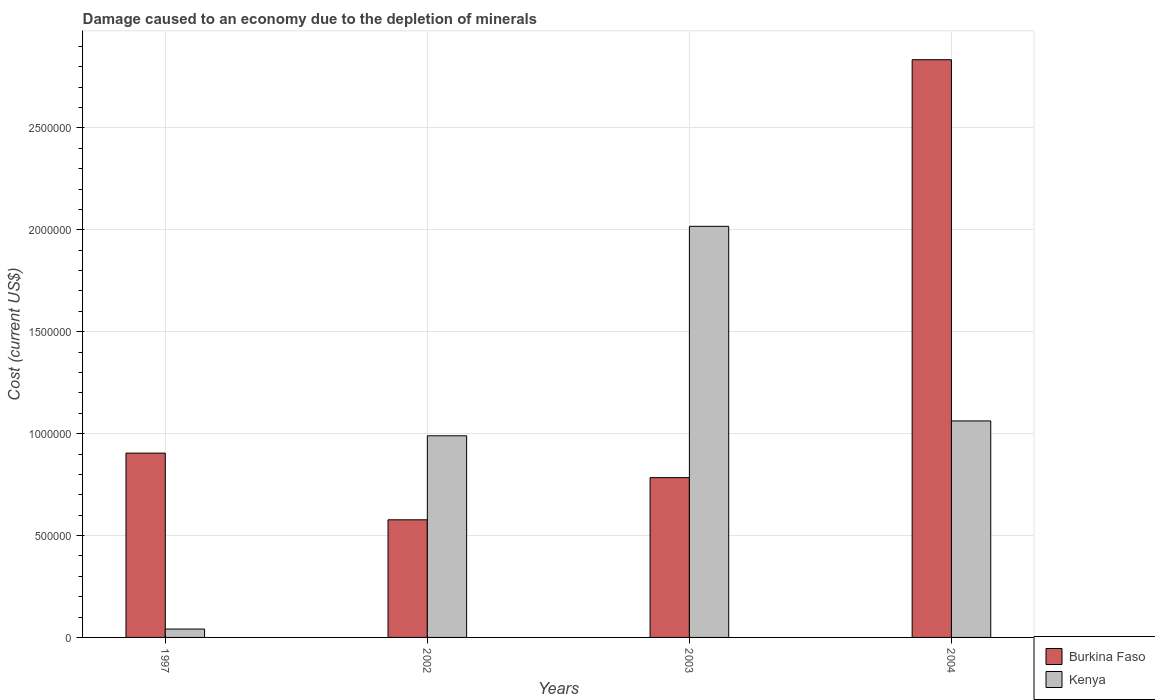How many different coloured bars are there?
Your answer should be very brief. 2. How many groups of bars are there?
Provide a short and direct response. 4. Are the number of bars per tick equal to the number of legend labels?
Keep it short and to the point. Yes. How many bars are there on the 2nd tick from the left?
Your answer should be very brief. 2. What is the label of the 2nd group of bars from the left?
Your answer should be very brief. 2002. In how many cases, is the number of bars for a given year not equal to the number of legend labels?
Your answer should be compact. 0. What is the cost of damage caused due to the depletion of minerals in Kenya in 2002?
Your response must be concise. 9.89e+05. Across all years, what is the maximum cost of damage caused due to the depletion of minerals in Kenya?
Ensure brevity in your answer.  2.02e+06. Across all years, what is the minimum cost of damage caused due to the depletion of minerals in Kenya?
Make the answer very short. 4.12e+04. In which year was the cost of damage caused due to the depletion of minerals in Burkina Faso maximum?
Your answer should be compact. 2004. What is the total cost of damage caused due to the depletion of minerals in Kenya in the graph?
Your answer should be very brief. 4.11e+06. What is the difference between the cost of damage caused due to the depletion of minerals in Burkina Faso in 1997 and that in 2002?
Keep it short and to the point. 3.27e+05. What is the difference between the cost of damage caused due to the depletion of minerals in Kenya in 2003 and the cost of damage caused due to the depletion of minerals in Burkina Faso in 2002?
Your response must be concise. 1.44e+06. What is the average cost of damage caused due to the depletion of minerals in Kenya per year?
Offer a very short reply. 1.03e+06. In the year 2004, what is the difference between the cost of damage caused due to the depletion of minerals in Kenya and cost of damage caused due to the depletion of minerals in Burkina Faso?
Your response must be concise. -1.77e+06. What is the ratio of the cost of damage caused due to the depletion of minerals in Kenya in 2003 to that in 2004?
Provide a succinct answer. 1.9. Is the difference between the cost of damage caused due to the depletion of minerals in Kenya in 2002 and 2003 greater than the difference between the cost of damage caused due to the depletion of minerals in Burkina Faso in 2002 and 2003?
Provide a short and direct response. No. What is the difference between the highest and the second highest cost of damage caused due to the depletion of minerals in Kenya?
Offer a terse response. 9.55e+05. What is the difference between the highest and the lowest cost of damage caused due to the depletion of minerals in Kenya?
Offer a very short reply. 1.98e+06. Is the sum of the cost of damage caused due to the depletion of minerals in Burkina Faso in 1997 and 2003 greater than the maximum cost of damage caused due to the depletion of minerals in Kenya across all years?
Your response must be concise. No. What does the 2nd bar from the left in 2003 represents?
Your answer should be compact. Kenya. What does the 1st bar from the right in 2003 represents?
Give a very brief answer. Kenya. How many bars are there?
Keep it short and to the point. 8. Are all the bars in the graph horizontal?
Offer a terse response. No. How many years are there in the graph?
Provide a short and direct response. 4. What is the difference between two consecutive major ticks on the Y-axis?
Provide a short and direct response. 5.00e+05. Where does the legend appear in the graph?
Make the answer very short. Bottom right. How many legend labels are there?
Provide a succinct answer. 2. What is the title of the graph?
Your answer should be very brief. Damage caused to an economy due to the depletion of minerals. What is the label or title of the Y-axis?
Your response must be concise. Cost (current US$). What is the Cost (current US$) in Burkina Faso in 1997?
Keep it short and to the point. 9.04e+05. What is the Cost (current US$) of Kenya in 1997?
Your response must be concise. 4.12e+04. What is the Cost (current US$) of Burkina Faso in 2002?
Your response must be concise. 5.77e+05. What is the Cost (current US$) of Kenya in 2002?
Your answer should be compact. 9.89e+05. What is the Cost (current US$) of Burkina Faso in 2003?
Provide a short and direct response. 7.84e+05. What is the Cost (current US$) in Kenya in 2003?
Offer a terse response. 2.02e+06. What is the Cost (current US$) in Burkina Faso in 2004?
Your response must be concise. 2.83e+06. What is the Cost (current US$) in Kenya in 2004?
Make the answer very short. 1.06e+06. Across all years, what is the maximum Cost (current US$) in Burkina Faso?
Ensure brevity in your answer.  2.83e+06. Across all years, what is the maximum Cost (current US$) in Kenya?
Your response must be concise. 2.02e+06. Across all years, what is the minimum Cost (current US$) in Burkina Faso?
Provide a short and direct response. 5.77e+05. Across all years, what is the minimum Cost (current US$) of Kenya?
Your answer should be compact. 4.12e+04. What is the total Cost (current US$) in Burkina Faso in the graph?
Keep it short and to the point. 5.10e+06. What is the total Cost (current US$) of Kenya in the graph?
Ensure brevity in your answer.  4.11e+06. What is the difference between the Cost (current US$) of Burkina Faso in 1997 and that in 2002?
Make the answer very short. 3.27e+05. What is the difference between the Cost (current US$) of Kenya in 1997 and that in 2002?
Offer a very short reply. -9.48e+05. What is the difference between the Cost (current US$) in Burkina Faso in 1997 and that in 2003?
Ensure brevity in your answer.  1.20e+05. What is the difference between the Cost (current US$) in Kenya in 1997 and that in 2003?
Make the answer very short. -1.98e+06. What is the difference between the Cost (current US$) of Burkina Faso in 1997 and that in 2004?
Offer a very short reply. -1.93e+06. What is the difference between the Cost (current US$) in Kenya in 1997 and that in 2004?
Offer a terse response. -1.02e+06. What is the difference between the Cost (current US$) of Burkina Faso in 2002 and that in 2003?
Offer a very short reply. -2.07e+05. What is the difference between the Cost (current US$) of Kenya in 2002 and that in 2003?
Offer a terse response. -1.03e+06. What is the difference between the Cost (current US$) of Burkina Faso in 2002 and that in 2004?
Your answer should be compact. -2.26e+06. What is the difference between the Cost (current US$) of Kenya in 2002 and that in 2004?
Your response must be concise. -7.29e+04. What is the difference between the Cost (current US$) of Burkina Faso in 2003 and that in 2004?
Your answer should be very brief. -2.05e+06. What is the difference between the Cost (current US$) in Kenya in 2003 and that in 2004?
Offer a terse response. 9.55e+05. What is the difference between the Cost (current US$) of Burkina Faso in 1997 and the Cost (current US$) of Kenya in 2002?
Offer a very short reply. -8.50e+04. What is the difference between the Cost (current US$) in Burkina Faso in 1997 and the Cost (current US$) in Kenya in 2003?
Your answer should be very brief. -1.11e+06. What is the difference between the Cost (current US$) in Burkina Faso in 1997 and the Cost (current US$) in Kenya in 2004?
Provide a succinct answer. -1.58e+05. What is the difference between the Cost (current US$) of Burkina Faso in 2002 and the Cost (current US$) of Kenya in 2003?
Offer a very short reply. -1.44e+06. What is the difference between the Cost (current US$) of Burkina Faso in 2002 and the Cost (current US$) of Kenya in 2004?
Your answer should be very brief. -4.85e+05. What is the difference between the Cost (current US$) of Burkina Faso in 2003 and the Cost (current US$) of Kenya in 2004?
Your response must be concise. -2.78e+05. What is the average Cost (current US$) of Burkina Faso per year?
Ensure brevity in your answer.  1.28e+06. What is the average Cost (current US$) in Kenya per year?
Your response must be concise. 1.03e+06. In the year 1997, what is the difference between the Cost (current US$) in Burkina Faso and Cost (current US$) in Kenya?
Provide a short and direct response. 8.63e+05. In the year 2002, what is the difference between the Cost (current US$) in Burkina Faso and Cost (current US$) in Kenya?
Your answer should be very brief. -4.12e+05. In the year 2003, what is the difference between the Cost (current US$) in Burkina Faso and Cost (current US$) in Kenya?
Make the answer very short. -1.23e+06. In the year 2004, what is the difference between the Cost (current US$) of Burkina Faso and Cost (current US$) of Kenya?
Keep it short and to the point. 1.77e+06. What is the ratio of the Cost (current US$) in Burkina Faso in 1997 to that in 2002?
Provide a succinct answer. 1.57. What is the ratio of the Cost (current US$) in Kenya in 1997 to that in 2002?
Provide a succinct answer. 0.04. What is the ratio of the Cost (current US$) of Burkina Faso in 1997 to that in 2003?
Your response must be concise. 1.15. What is the ratio of the Cost (current US$) of Kenya in 1997 to that in 2003?
Provide a succinct answer. 0.02. What is the ratio of the Cost (current US$) of Burkina Faso in 1997 to that in 2004?
Ensure brevity in your answer.  0.32. What is the ratio of the Cost (current US$) of Kenya in 1997 to that in 2004?
Offer a very short reply. 0.04. What is the ratio of the Cost (current US$) in Burkina Faso in 2002 to that in 2003?
Provide a short and direct response. 0.74. What is the ratio of the Cost (current US$) in Kenya in 2002 to that in 2003?
Offer a very short reply. 0.49. What is the ratio of the Cost (current US$) in Burkina Faso in 2002 to that in 2004?
Make the answer very short. 0.2. What is the ratio of the Cost (current US$) in Kenya in 2002 to that in 2004?
Provide a succinct answer. 0.93. What is the ratio of the Cost (current US$) in Burkina Faso in 2003 to that in 2004?
Provide a short and direct response. 0.28. What is the ratio of the Cost (current US$) of Kenya in 2003 to that in 2004?
Provide a succinct answer. 1.9. What is the difference between the highest and the second highest Cost (current US$) in Burkina Faso?
Make the answer very short. 1.93e+06. What is the difference between the highest and the second highest Cost (current US$) in Kenya?
Make the answer very short. 9.55e+05. What is the difference between the highest and the lowest Cost (current US$) in Burkina Faso?
Your answer should be compact. 2.26e+06. What is the difference between the highest and the lowest Cost (current US$) of Kenya?
Your answer should be compact. 1.98e+06. 